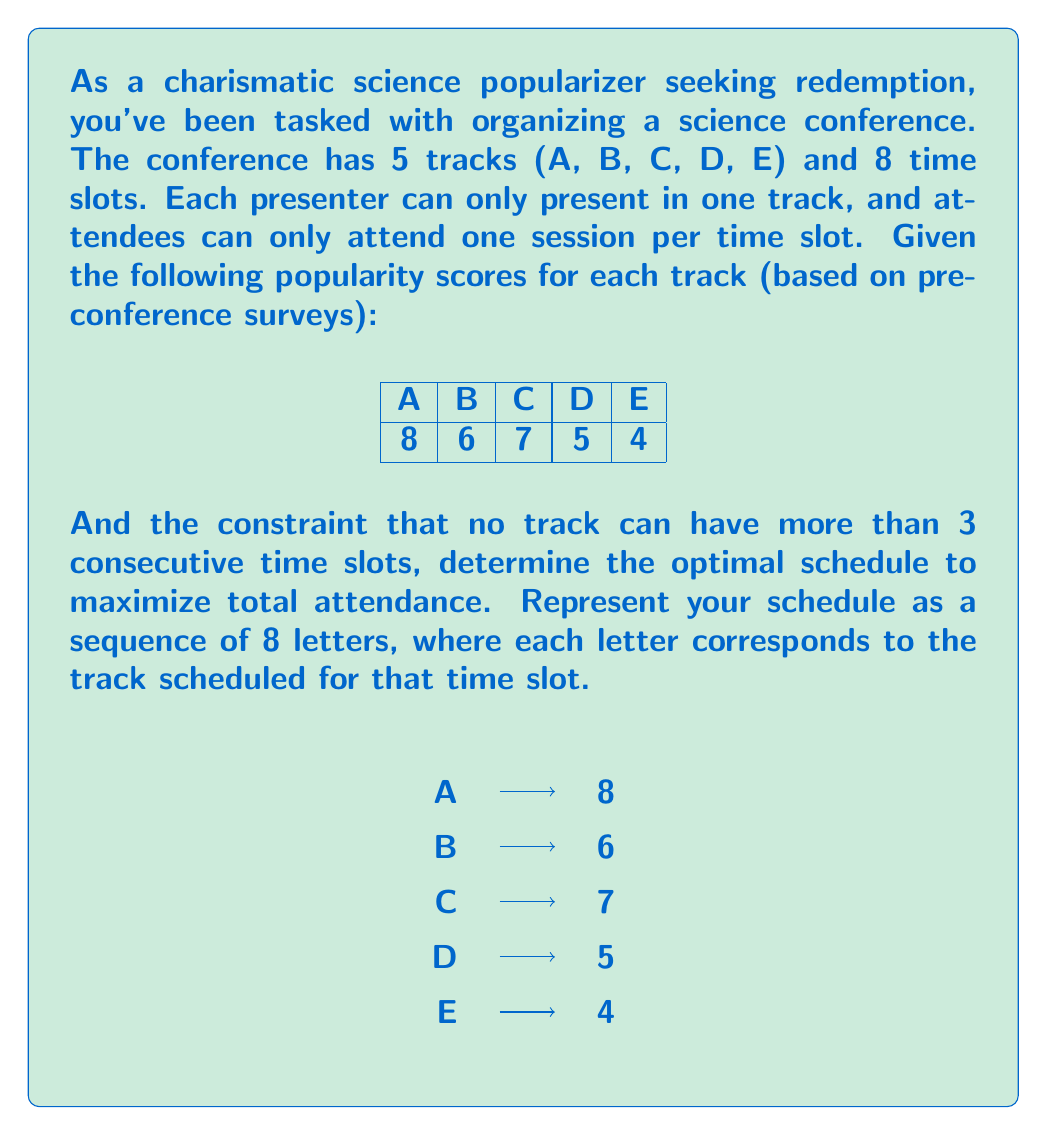Solve this math problem. To solve this optimization problem, we'll use a greedy algorithm approach with the given constraints. Here's the step-by-step process:

1) First, order the tracks by popularity:
   A (8), C (7), B (6), D (5), E (4)

2) Start filling the schedule with the most popular track (A) until we hit the consecutive slot constraint:
   A A A _ _ _ _ _

3) Move to the next most popular track (C) and fill until constraint or all slots are filled:
   A A A C C C _ _

4) Continue with the next track (B):
   A A A C C C B B

5) The schedule is now complete and optimized within the given constraints.

6) Calculate the total attendance score:
   $$ 8 + 8 + 8 + 7 + 7 + 7 + 6 + 6 = 57 $$

This approach ensures maximum attendance while adhering to the constraint of no more than 3 consecutive slots for any track.

Note: While this greedy approach works well for this specific problem, it may not always yield the optimal solution for all scheduling problems. More complex scenarios might require dynamic programming or other advanced optimization techniques.
Answer: AAACCCBB 